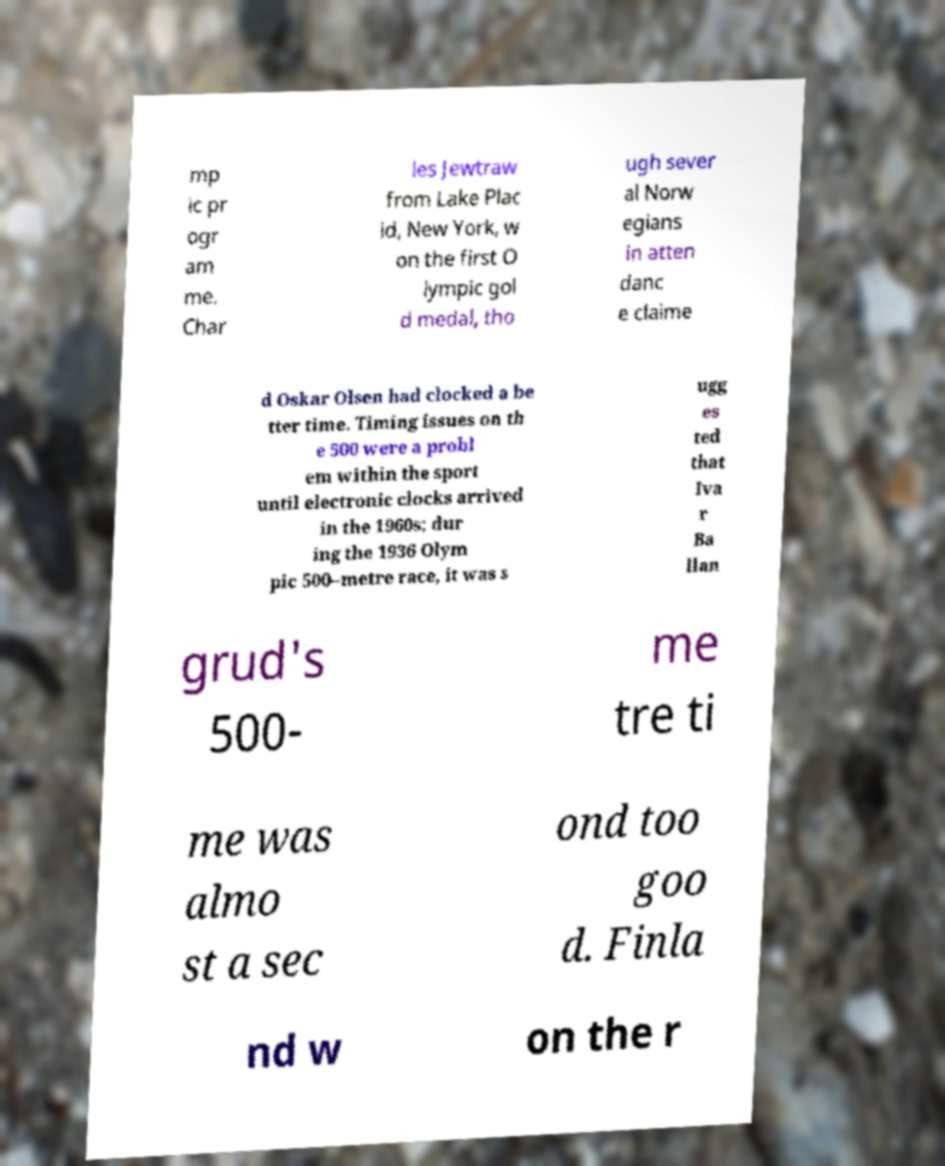Please identify and transcribe the text found in this image. mp ic pr ogr am me. Char les Jewtraw from Lake Plac id, New York, w on the first O lympic gol d medal, tho ugh sever al Norw egians in atten danc e claime d Oskar Olsen had clocked a be tter time. Timing issues on th e 500 were a probl em within the sport until electronic clocks arrived in the 1960s; dur ing the 1936 Olym pic 500–metre race, it was s ugg es ted that Iva r Ba llan grud's 500- me tre ti me was almo st a sec ond too goo d. Finla nd w on the r 